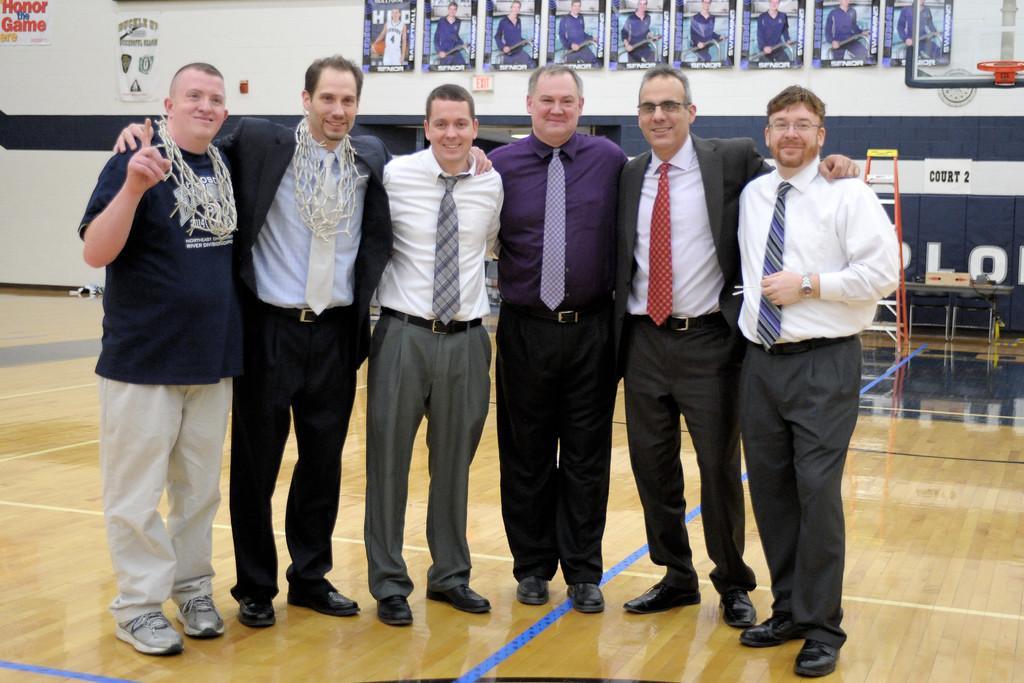In one or two sentences, can you explain what this image depicts? In this picture we can see six men standing on the ground and smiling and at the back of them we can see posters on the wall, ladder and some objects. 